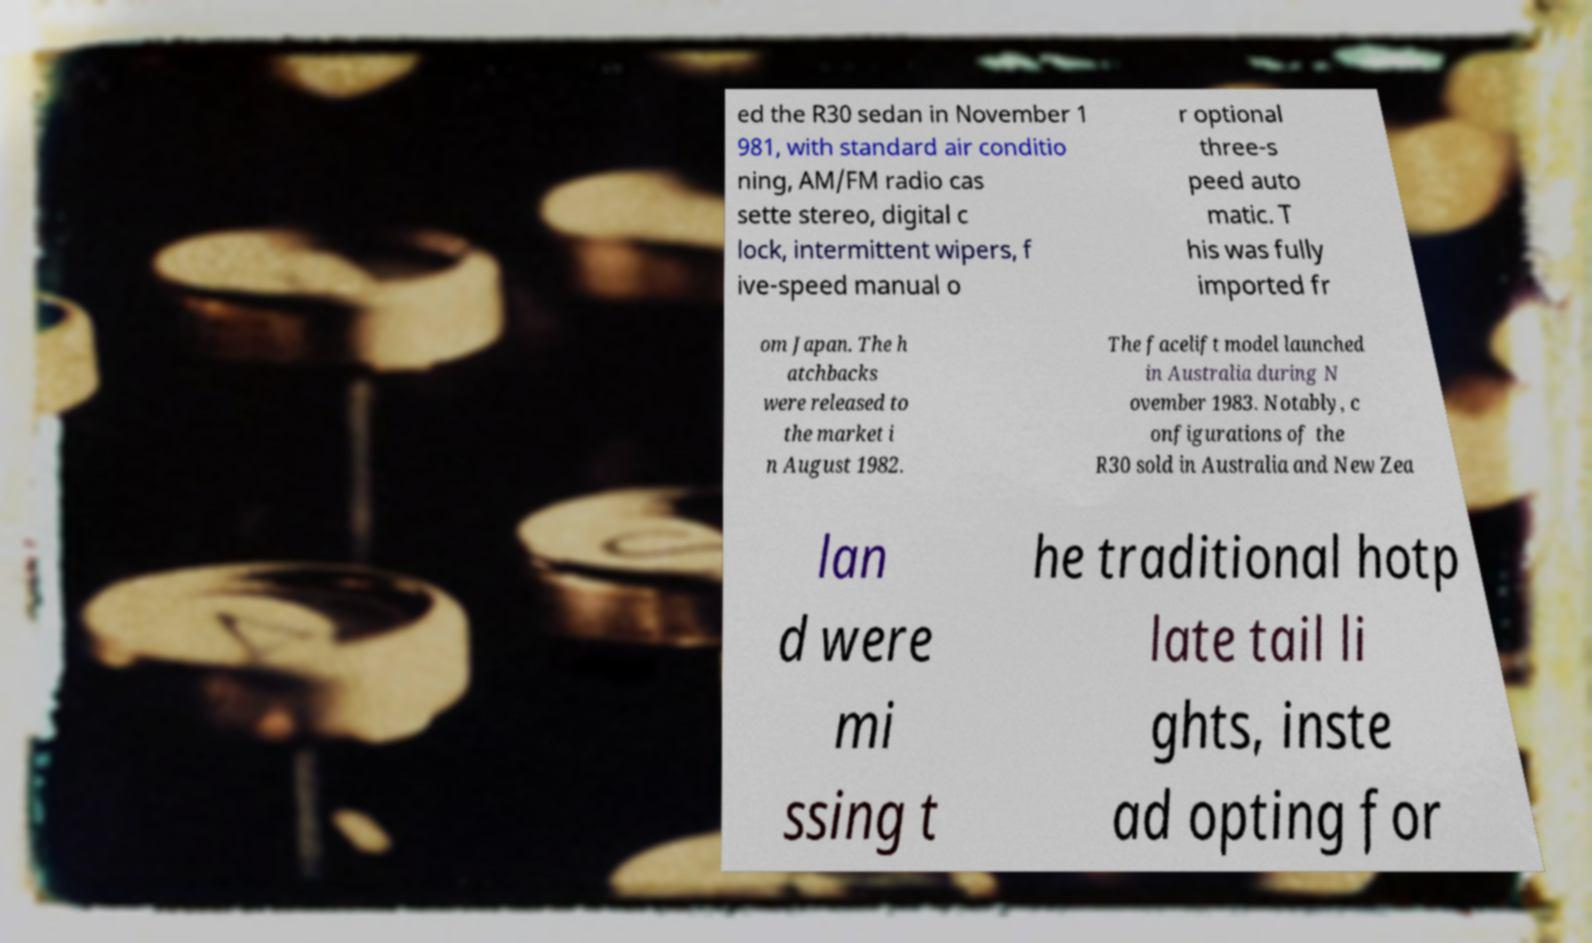Can you read and provide the text displayed in the image?This photo seems to have some interesting text. Can you extract and type it out for me? ed the R30 sedan in November 1 981, with standard air conditio ning, AM/FM radio cas sette stereo, digital c lock, intermittent wipers, f ive-speed manual o r optional three-s peed auto matic. T his was fully imported fr om Japan. The h atchbacks were released to the market i n August 1982. The facelift model launched in Australia during N ovember 1983. Notably, c onfigurations of the R30 sold in Australia and New Zea lan d were mi ssing t he traditional hotp late tail li ghts, inste ad opting for 